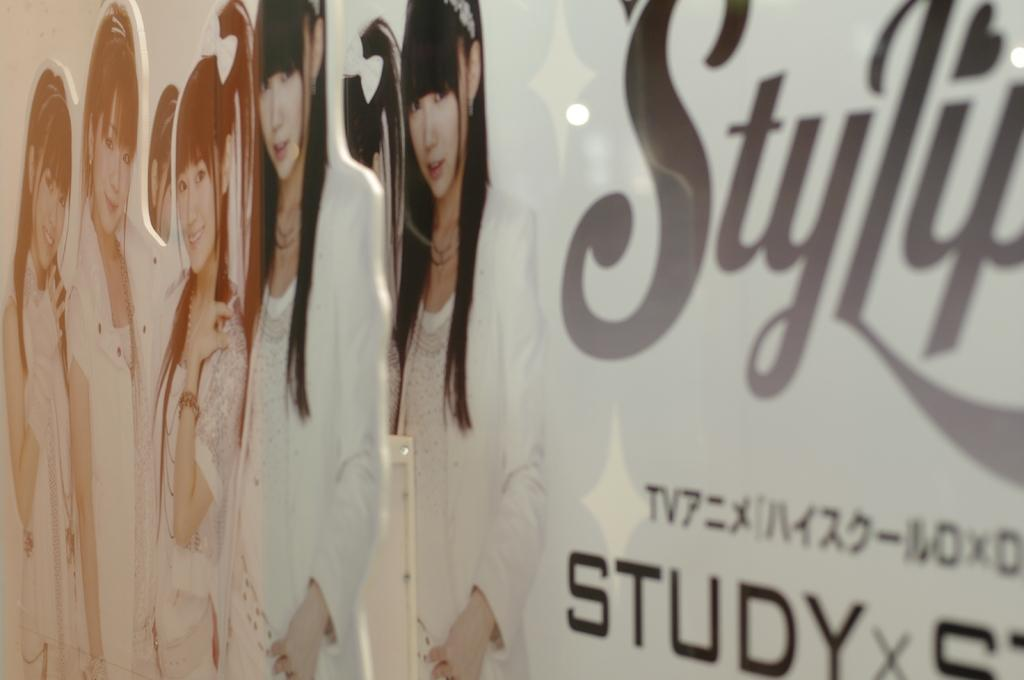What is the main object in the image? There is a board in the image. What can be found on the right side of the board? There is text on the right side of the board. What is depicted on the left side of the board? There are pictures of women on the left side of the board. How many wheels can be seen on the board in the image? There are no wheels present on the board in the image. What sound do the women on the board make when they sneeze? There is no indication of sound or action from the women in the image, as they are depicted in pictures. 